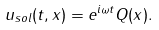<formula> <loc_0><loc_0><loc_500><loc_500>u _ { s o l } ( t , x ) = e ^ { i \omega t } Q ( x ) .</formula> 